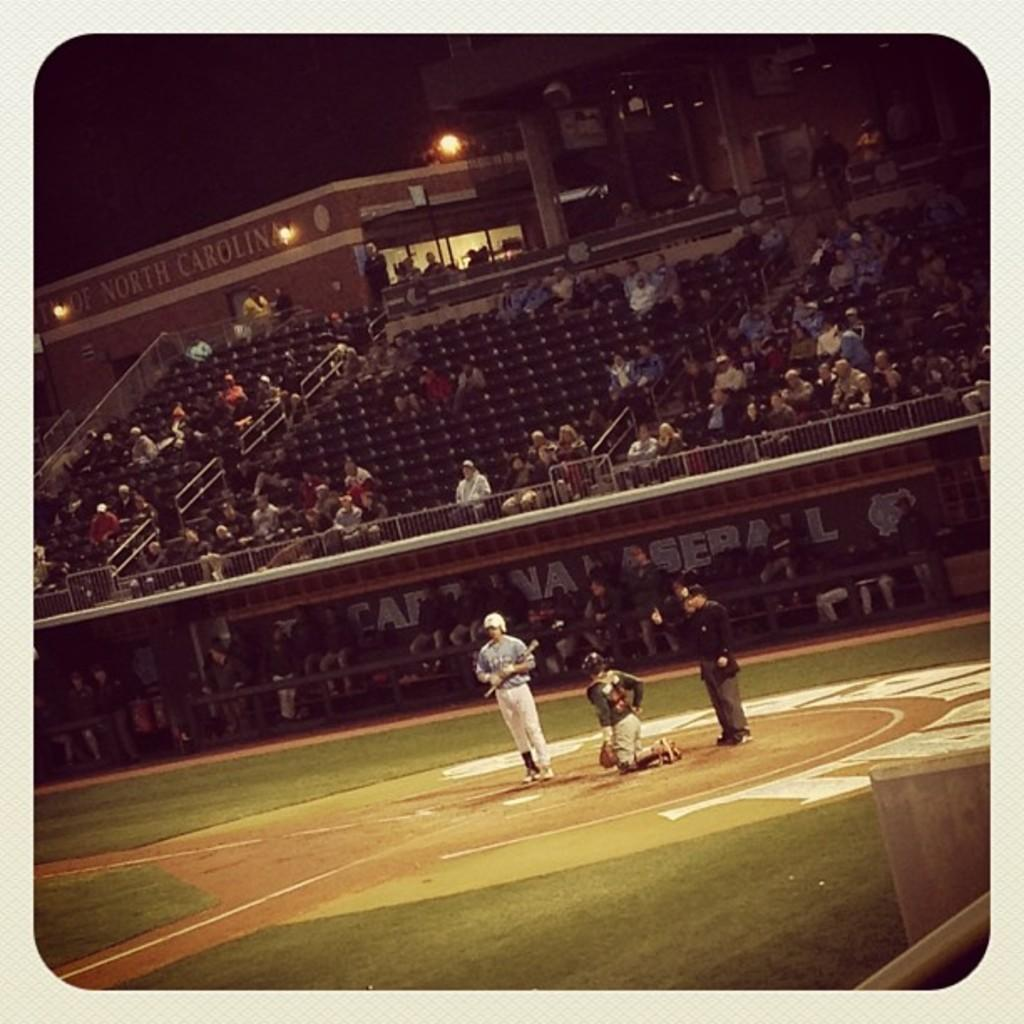<image>
Provide a brief description of the given image. a baseball game with the word baseball in the dugout 